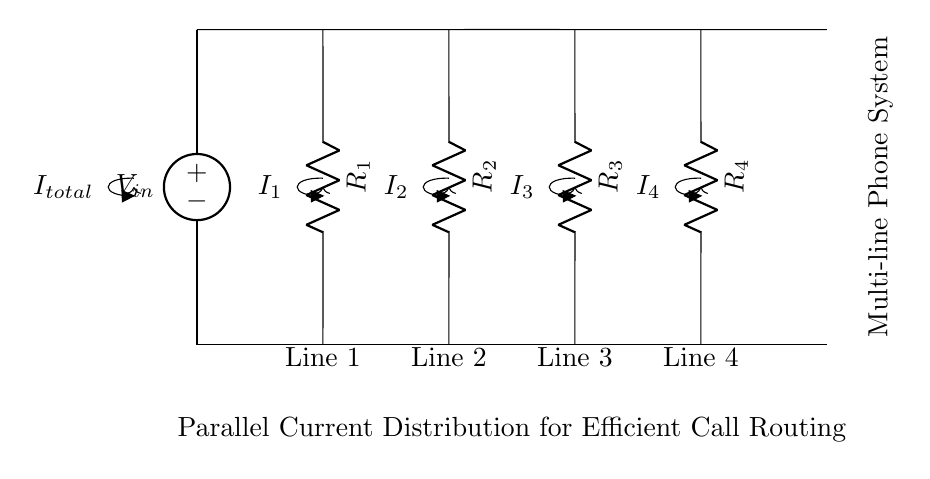What is the total current entering the circuit? The total current entering the circuit is labeled as I total, which represents the sum of the currents flowing through all the parallel branches (lines).
Answer: I total How many resistors are shown in the circuit? There are four resistors labeled R1, R2, R3, and R4. Each resistor corresponds to a separate line in the parallel configuration.
Answer: 4 What type of circuit configuration is used in this diagram? The circuit configuration depicted is a parallel circuit, as indicated by multiple paths for current to flow, each through separate resistors.
Answer: Parallel Which resistor corresponds to Line 3? Line 3 is connected to resistor R3, which is positioned in the middle of the circuit representation.
Answer: R3 If R1 is replaced with a higher resistance, how will I1 change? If resistance R1 increases, the current I1 will decrease according to Ohm's Law, which states that current is inversely proportional to resistance for a given voltage.
Answer: Decrease What does the voltage source represent in this circuit? The voltage source labeled as V in indicates the input voltage supplied to the entire circuit and influences the distribution of currents through each branch.
Answer: V in What is the relationship between the currents I1, I2, I3, and I4? The relationship is given by the current divider rule, where the total current I total is distributed among the resistors in inverse proportion to their resistances.
Answer: I total 